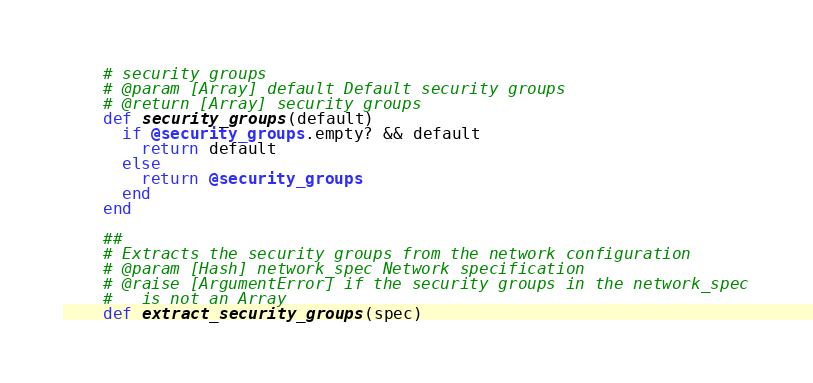Convert code to text. <code><loc_0><loc_0><loc_500><loc_500><_Ruby_>    # security groups
    # @param [Array] default Default security groups
    # @return [Array] security groups
    def security_groups(default)
      if @security_groups.empty? && default
        return default
      else
        return @security_groups
      end
    end

    ##
    # Extracts the security groups from the network configuration
    # @param [Hash] network_spec Network specification
    # @raise [ArgumentError] if the security groups in the network_spec
    #   is not an Array
    def extract_security_groups(spec)</code> 